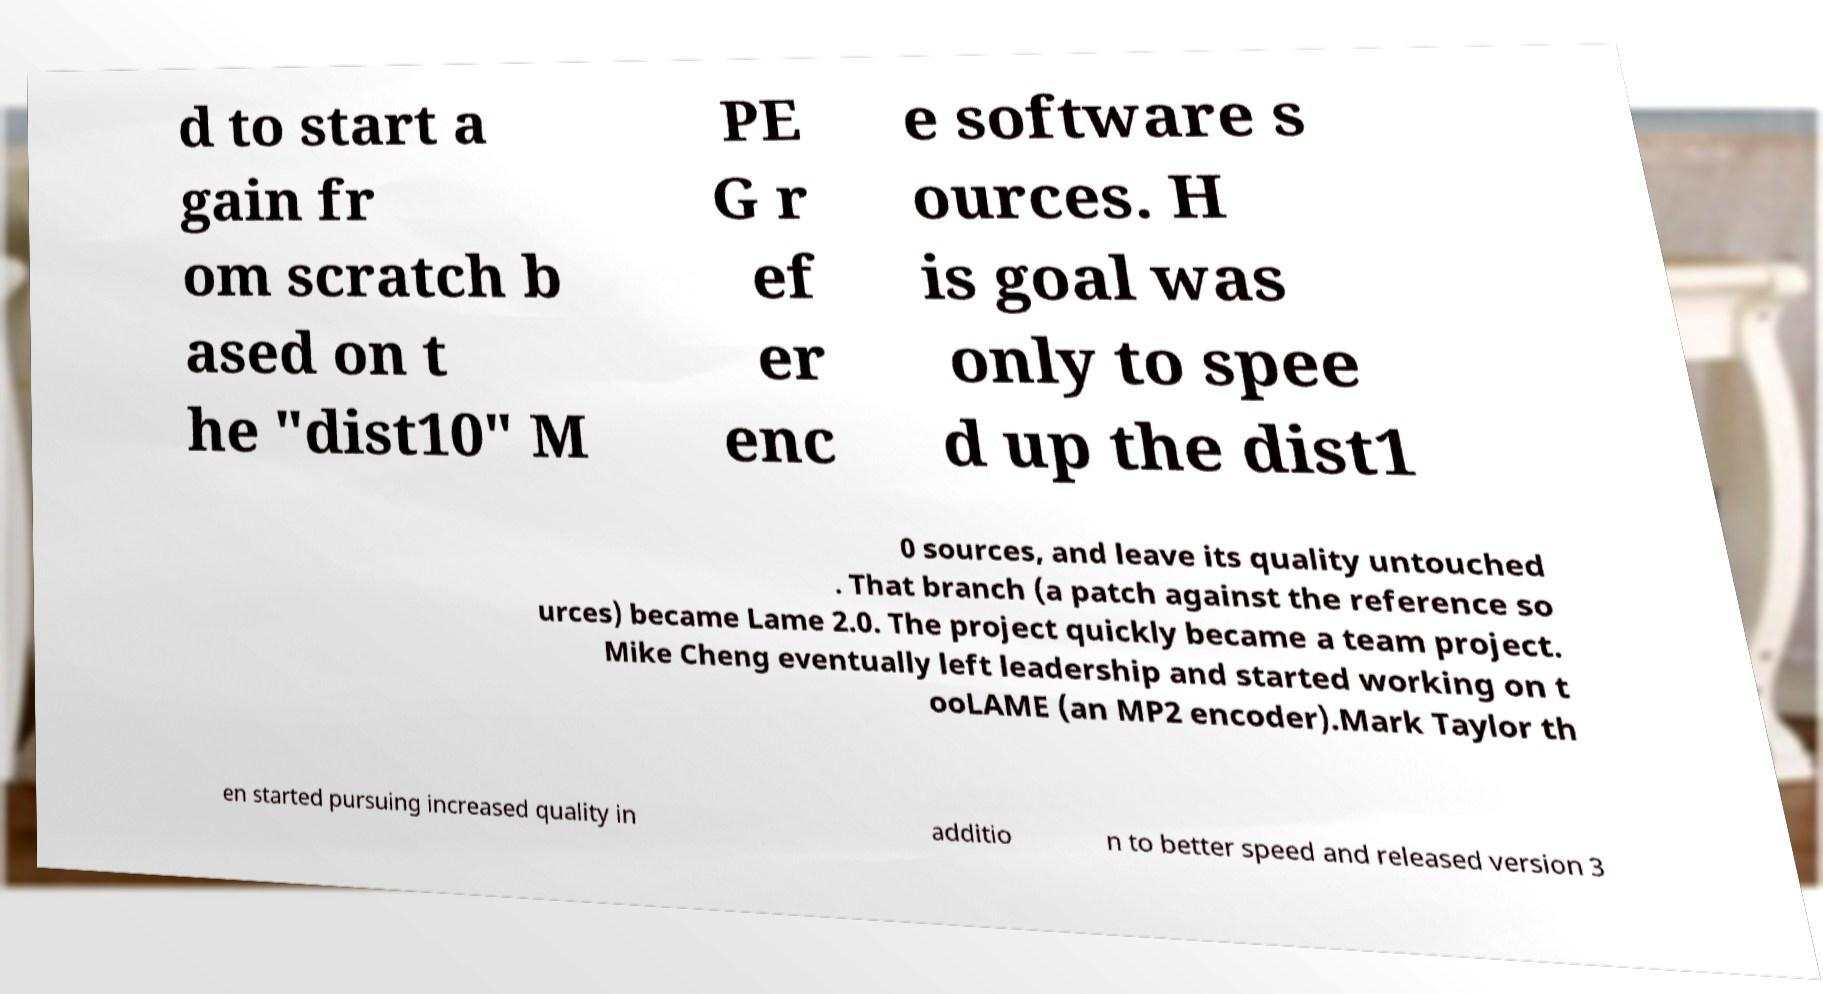Could you extract and type out the text from this image? d to start a gain fr om scratch b ased on t he "dist10" M PE G r ef er enc e software s ources. H is goal was only to spee d up the dist1 0 sources, and leave its quality untouched . That branch (a patch against the reference so urces) became Lame 2.0. The project quickly became a team project. Mike Cheng eventually left leadership and started working on t ooLAME (an MP2 encoder).Mark Taylor th en started pursuing increased quality in additio n to better speed and released version 3 